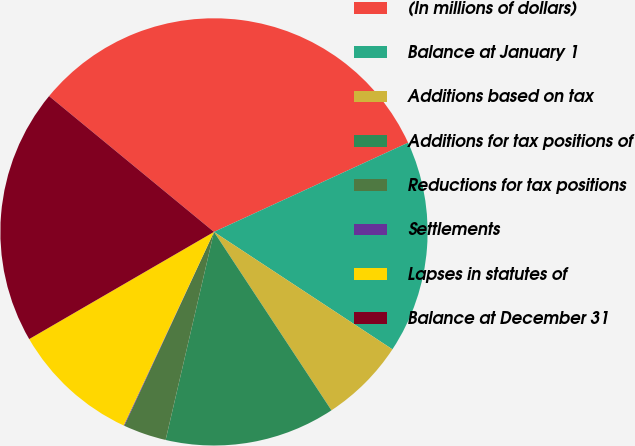Convert chart to OTSL. <chart><loc_0><loc_0><loc_500><loc_500><pie_chart><fcel>(In millions of dollars)<fcel>Balance at January 1<fcel>Additions based on tax<fcel>Additions for tax positions of<fcel>Reductions for tax positions<fcel>Settlements<fcel>Lapses in statutes of<fcel>Balance at December 31<nl><fcel>32.18%<fcel>16.12%<fcel>6.47%<fcel>12.9%<fcel>3.26%<fcel>0.05%<fcel>9.69%<fcel>19.33%<nl></chart> 